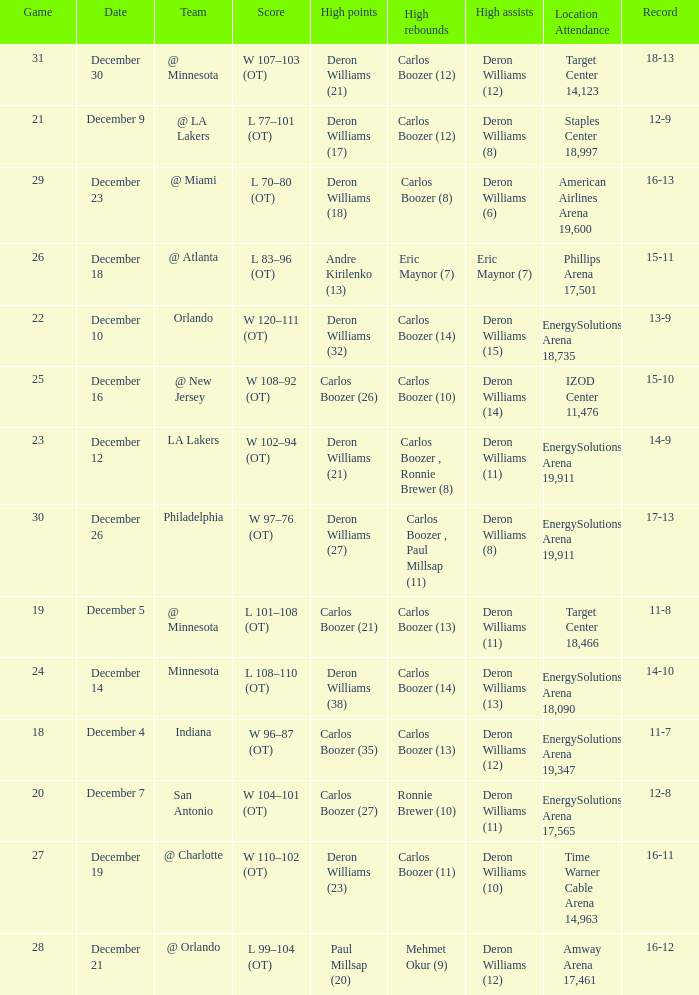What's the number of the game in which Carlos Boozer (8) did the high rebounds? 29.0. 